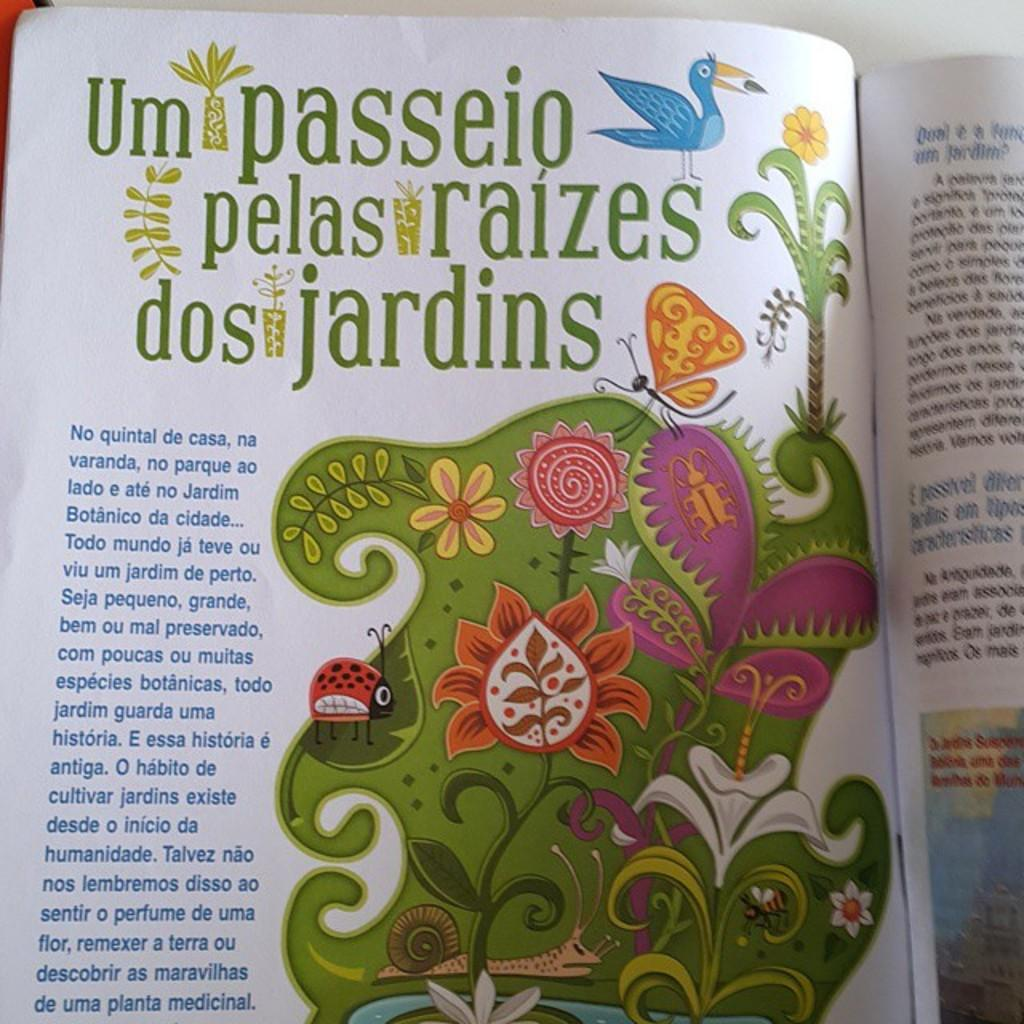<image>
Provide a brief description of the given image. A colorful printed page written in Spanish discusses botanicas and jardins. 